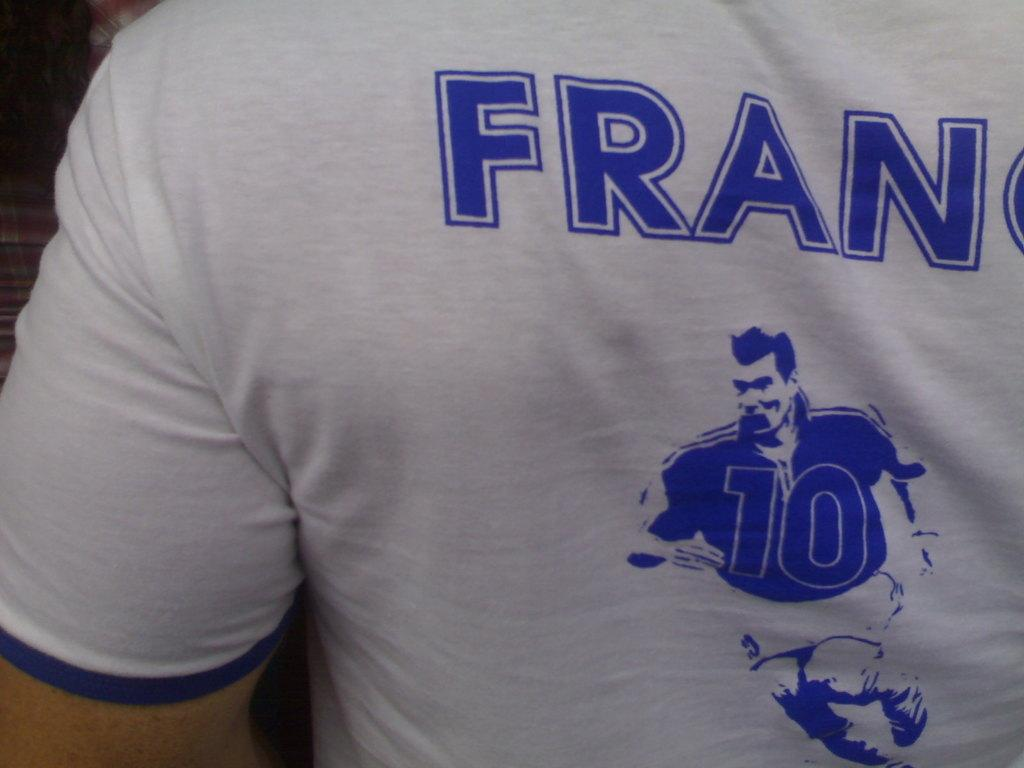<image>
Render a clear and concise summary of the photo. A t-shirt displays an illustration of a running athlete with the number 10 n his uniform. 